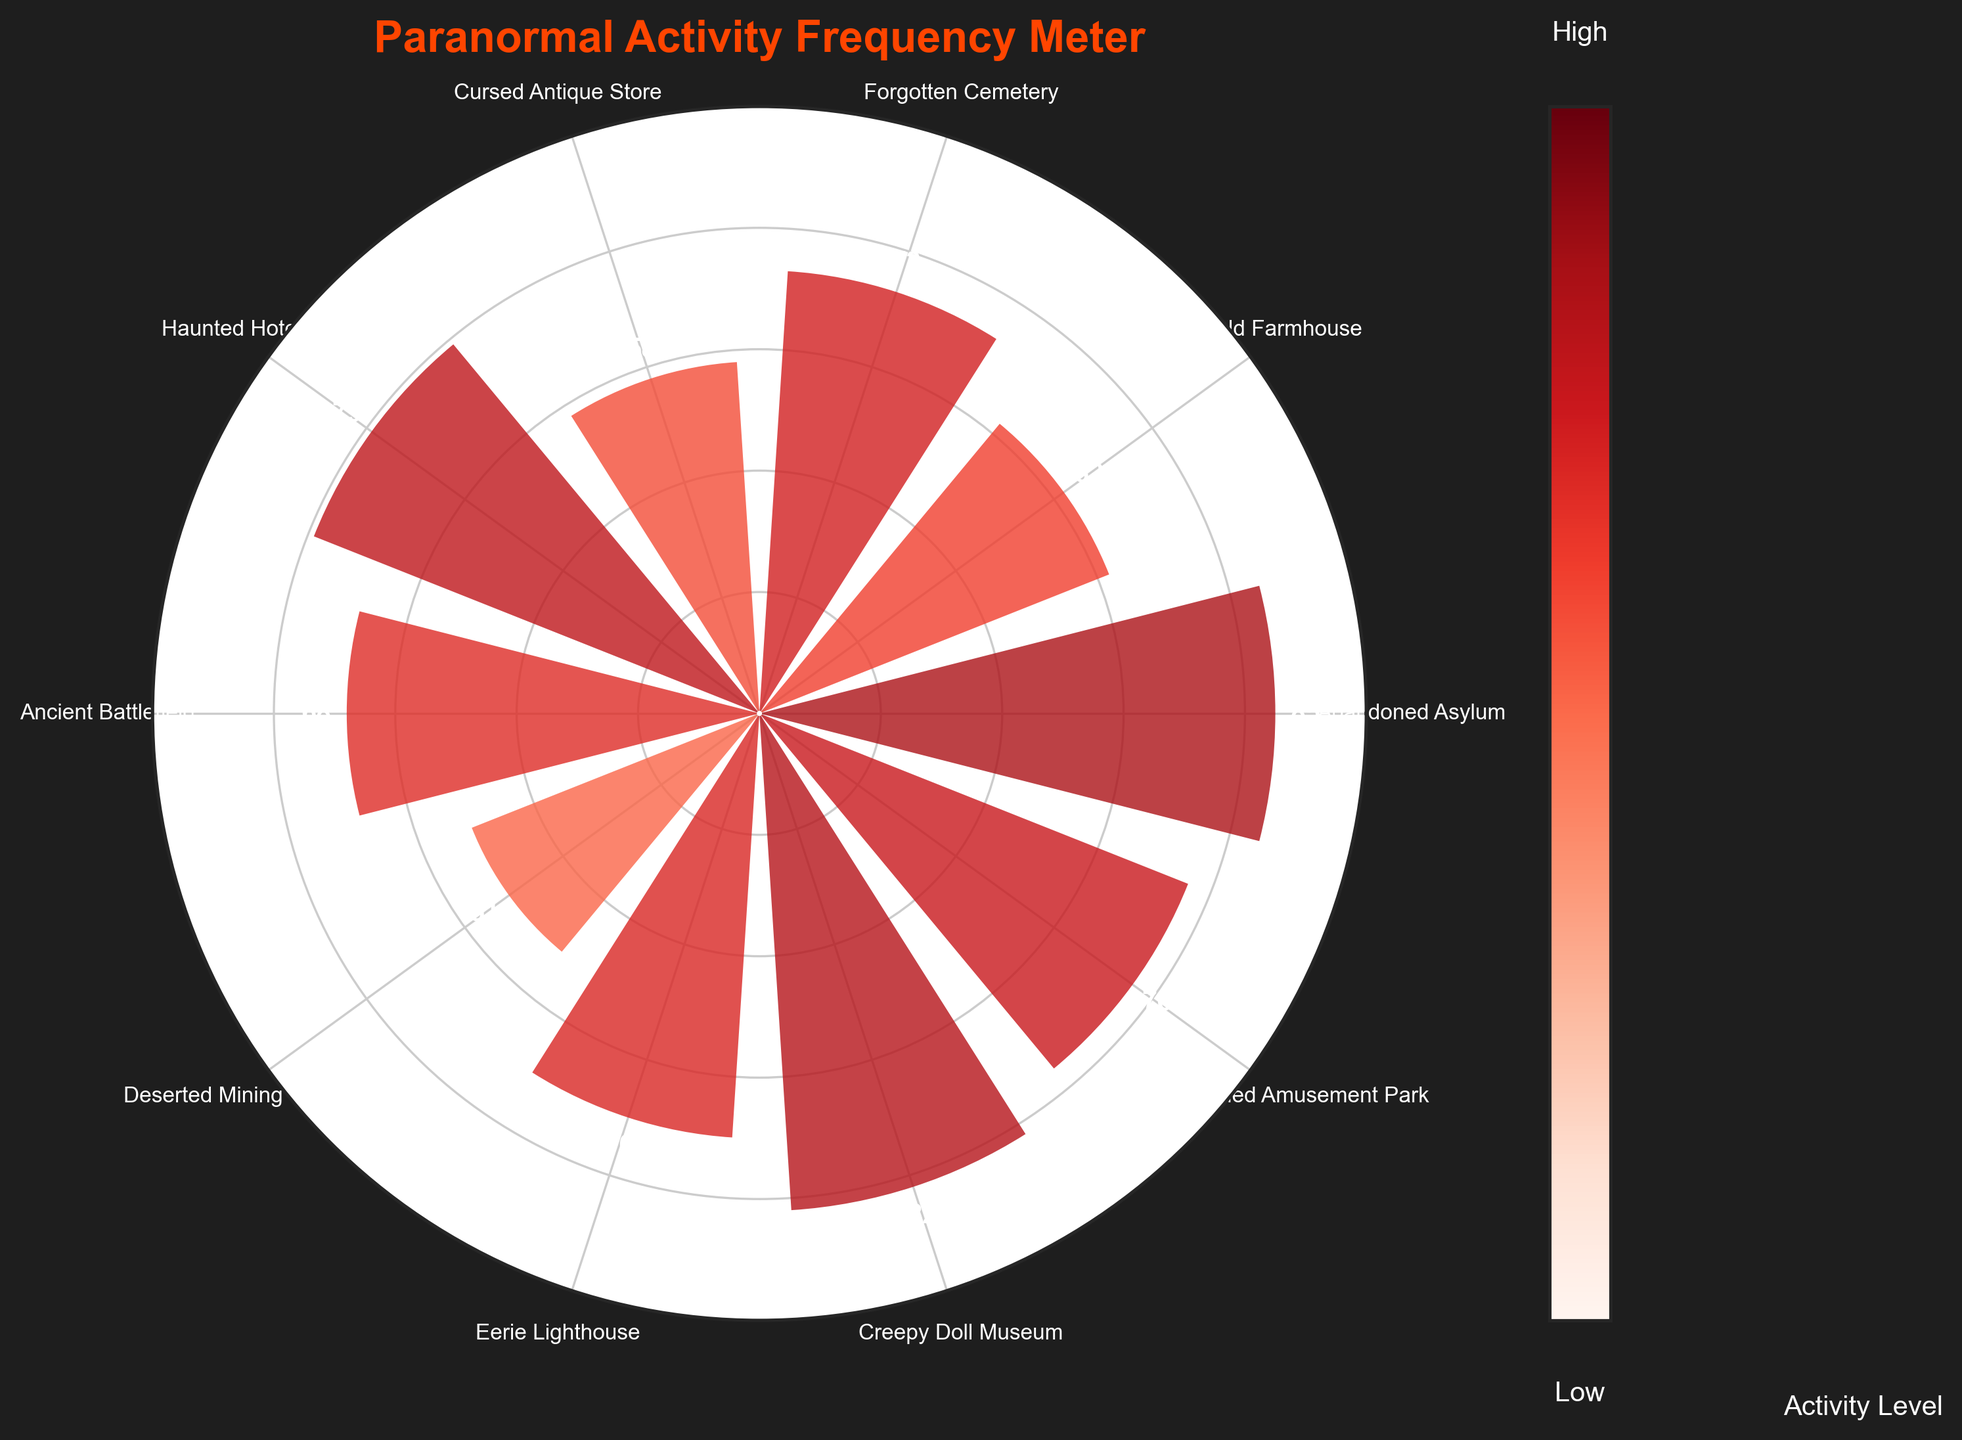What's the title of the chart? Look at the top of the chart where the title is usually positioned.
Answer: Paranormal Activity Frequency Meter How many haunted locations are represented on the chart? Count the number of distinct labels or bars around the polar plot.
Answer: 10 Which location has the highest activity level? Check the bar that reaches the highest value on the scale and note its associated label.
Answer: Abandoned Asylum Which location has the lowest activity level? Look for the bar that is the shortest and note its corresponding label.
Answer: Deserted Mining Town What is the activity level of the Haunted Hotel? Find the label "Haunted Hotel" and read the value associated with its bar.
Answer: 79 What's the combined activity level of the Forgotten Cemetery and the Cursed Antique Store? Find the respective activity levels and sum them up: 73 for Forgotten Cemetery and 58 for Cursed Antique Store. 73 + 58 = 131
Answer: 131 What's the average activity level of all locations? Sum up the activity levels of all locations and divide by the number of locations (85+62+73+58+79+68+51+70+82+76)/10 = 70.4
Answer: 70.4 Which locations have activity levels greater than 75? Identify the labels with bars reaching beyond the 75 mark.
Answer: Abandoned Asylum, Haunted Hotel, Creepy Doll Museum, Abandoned Amusement Park How many locations have an activity level below 60? Count the bars that fall below the 60 mark.
Answer: 2 Which location has an activity level closest to 70? Find the bar whose value is nearest to 70, considering the associated labels and comparative values.
Answer: Eerie Lighthouse 